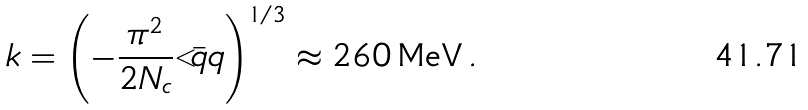<formula> <loc_0><loc_0><loc_500><loc_500>k = \left ( - \frac { \pi ^ { 2 } } { 2 N _ { c } } { < } \bar { q } { q } \right ) ^ { 1 / 3 } \approx 2 6 0 \, \text {MeV} \, .</formula> 